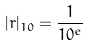<formula> <loc_0><loc_0><loc_500><loc_500>| r | _ { 1 0 } = \frac { 1 } { 1 0 ^ { e } }</formula> 